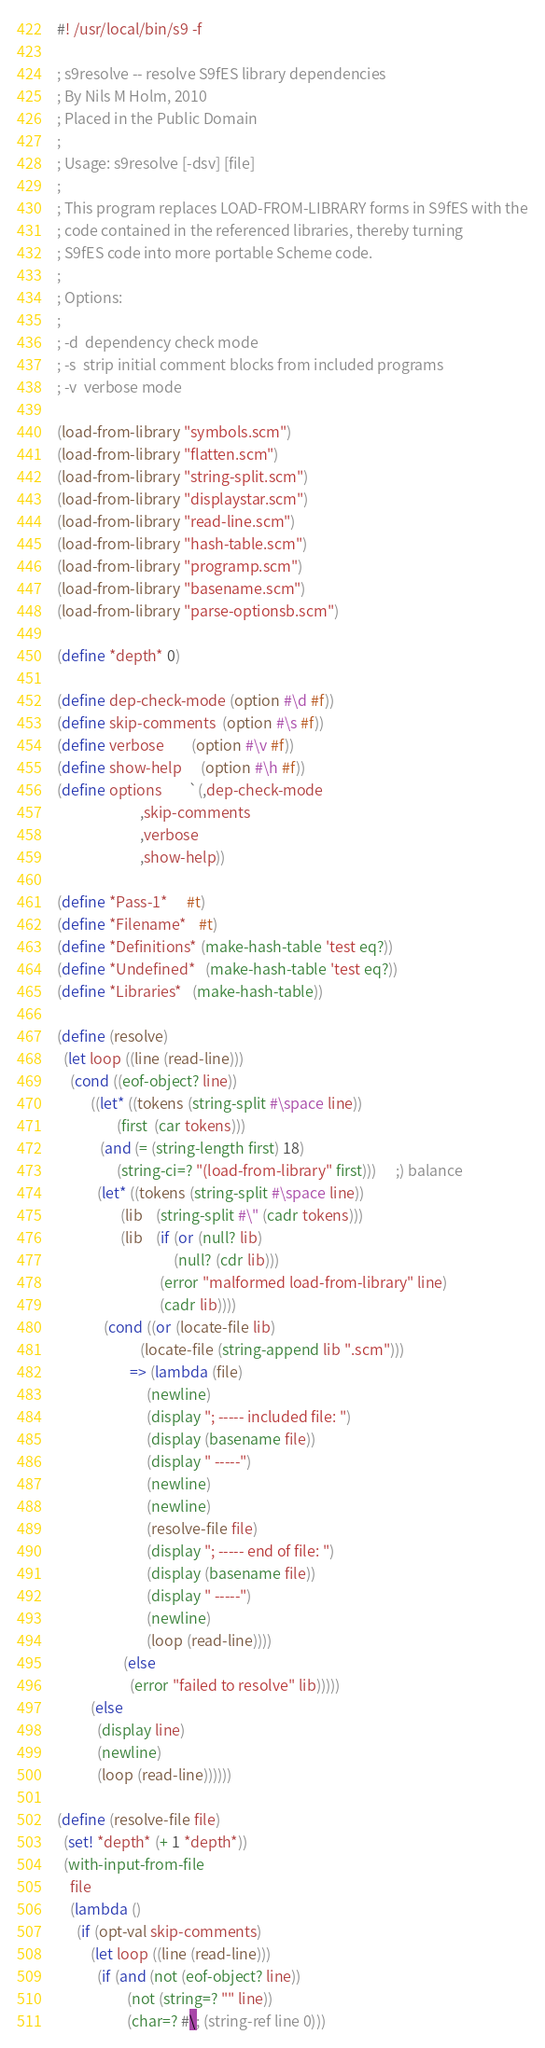<code> <loc_0><loc_0><loc_500><loc_500><_Scheme_>#! /usr/local/bin/s9 -f

; s9resolve -- resolve S9fES library dependencies
; By Nils M Holm, 2010
; Placed in the Public Domain
;
; Usage: s9resolve [-dsv] [file]
;
; This program replaces LOAD-FROM-LIBRARY forms in S9fES with the
; code contained in the referenced libraries, thereby turning
; S9fES code into more portable Scheme code.
;
; Options:
;
; -d  dependency check mode
; -s  strip initial comment blocks from included programs
; -v  verbose mode

(load-from-library "symbols.scm")
(load-from-library "flatten.scm")
(load-from-library "string-split.scm")
(load-from-library "displaystar.scm")
(load-from-library "read-line.scm")
(load-from-library "hash-table.scm")
(load-from-library "programp.scm")
(load-from-library "basename.scm")
(load-from-library "parse-optionsb.scm")

(define *depth* 0)

(define dep-check-mode (option #\d #f))
(define skip-comments  (option #\s #f))
(define verbose        (option #\v #f))
(define show-help      (option #\h #f))
(define options        `(,dep-check-mode
                         ,skip-comments
                         ,verbose
                         ,show-help))

(define *Pass-1*      #t)
(define *Filename*    #t)
(define *Definitions* (make-hash-table 'test eq?))
(define *Undefined*   (make-hash-table 'test eq?))
(define *Libraries*   (make-hash-table))

(define (resolve)
  (let loop ((line (read-line)))
    (cond ((eof-object? line))
          ((let* ((tokens (string-split #\space line))
                  (first  (car tokens)))
             (and (= (string-length first) 18)
                  (string-ci=? "(load-from-library" first)))      ;) balance
            (let* ((tokens (string-split #\space line))
                   (lib    (string-split #\" (cadr tokens)))
                   (lib    (if (or (null? lib)
                                   (null? (cdr lib)))
                               (error "malformed load-from-library" line)
                               (cadr lib))))
              (cond ((or (locate-file lib)
                         (locate-file (string-append lib ".scm")))
                      => (lambda (file)
                           (newline)
                           (display "; ----- included file: ")
                           (display (basename file))
                           (display " -----")
                           (newline)
                           (newline)
                           (resolve-file file)
                           (display "; ----- end of file: ")
                           (display (basename file))
                           (display " -----")
                           (newline)
                           (loop (read-line))))
                    (else
                      (error "failed to resolve" lib)))))
          (else
            (display line)
            (newline)
            (loop (read-line))))))

(define (resolve-file file)
  (set! *depth* (+ 1 *depth*))
  (with-input-from-file
    file
    (lambda ()
      (if (opt-val skip-comments)
          (let loop ((line (read-line)))
            (if (and (not (eof-object? line))
                     (not (string=? "" line))
                     (char=? #\; (string-ref line 0)))</code> 